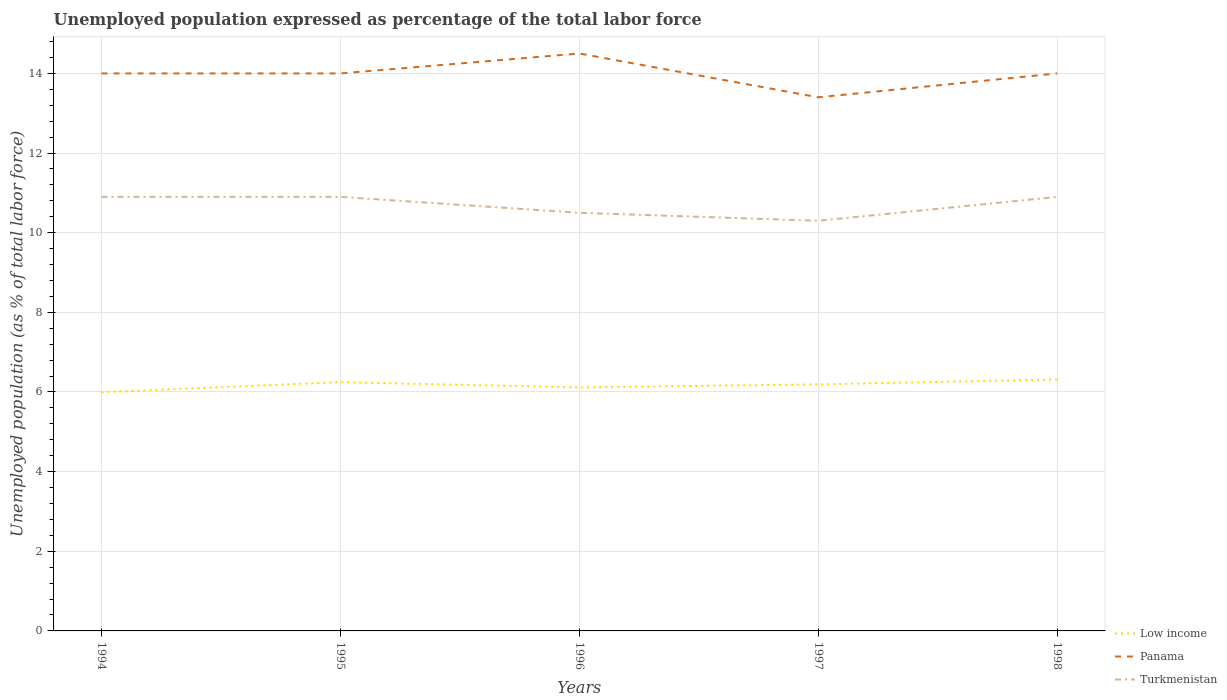Across all years, what is the maximum unemployment in in Turkmenistan?
Your answer should be very brief. 10.3. In which year was the unemployment in in Turkmenistan maximum?
Your answer should be compact. 1997. What is the total unemployment in in Low income in the graph?
Provide a succinct answer. -0.2. What is the difference between the highest and the second highest unemployment in in Low income?
Ensure brevity in your answer.  0.32. What is the difference between the highest and the lowest unemployment in in Low income?
Offer a terse response. 3. Are the values on the major ticks of Y-axis written in scientific E-notation?
Make the answer very short. No. How many legend labels are there?
Give a very brief answer. 3. How are the legend labels stacked?
Provide a short and direct response. Vertical. What is the title of the graph?
Make the answer very short. Unemployed population expressed as percentage of the total labor force. What is the label or title of the X-axis?
Ensure brevity in your answer.  Years. What is the label or title of the Y-axis?
Your answer should be compact. Unemployed population (as % of total labor force). What is the Unemployed population (as % of total labor force) in Low income in 1994?
Your response must be concise. 5.99. What is the Unemployed population (as % of total labor force) of Turkmenistan in 1994?
Keep it short and to the point. 10.9. What is the Unemployed population (as % of total labor force) of Low income in 1995?
Keep it short and to the point. 6.25. What is the Unemployed population (as % of total labor force) in Panama in 1995?
Offer a terse response. 14. What is the Unemployed population (as % of total labor force) in Turkmenistan in 1995?
Keep it short and to the point. 10.9. What is the Unemployed population (as % of total labor force) of Low income in 1996?
Make the answer very short. 6.12. What is the Unemployed population (as % of total labor force) in Turkmenistan in 1996?
Your response must be concise. 10.5. What is the Unemployed population (as % of total labor force) in Low income in 1997?
Keep it short and to the point. 6.19. What is the Unemployed population (as % of total labor force) of Panama in 1997?
Make the answer very short. 13.4. What is the Unemployed population (as % of total labor force) of Turkmenistan in 1997?
Provide a short and direct response. 10.3. What is the Unemployed population (as % of total labor force) in Low income in 1998?
Give a very brief answer. 6.31. What is the Unemployed population (as % of total labor force) of Panama in 1998?
Offer a terse response. 14. What is the Unemployed population (as % of total labor force) in Turkmenistan in 1998?
Ensure brevity in your answer.  10.9. Across all years, what is the maximum Unemployed population (as % of total labor force) in Low income?
Make the answer very short. 6.31. Across all years, what is the maximum Unemployed population (as % of total labor force) of Panama?
Provide a succinct answer. 14.5. Across all years, what is the maximum Unemployed population (as % of total labor force) in Turkmenistan?
Make the answer very short. 10.9. Across all years, what is the minimum Unemployed population (as % of total labor force) in Low income?
Offer a terse response. 5.99. Across all years, what is the minimum Unemployed population (as % of total labor force) of Panama?
Make the answer very short. 13.4. Across all years, what is the minimum Unemployed population (as % of total labor force) of Turkmenistan?
Provide a short and direct response. 10.3. What is the total Unemployed population (as % of total labor force) in Low income in the graph?
Your answer should be very brief. 30.86. What is the total Unemployed population (as % of total labor force) of Panama in the graph?
Offer a terse response. 69.9. What is the total Unemployed population (as % of total labor force) of Turkmenistan in the graph?
Offer a terse response. 53.5. What is the difference between the Unemployed population (as % of total labor force) in Low income in 1994 and that in 1995?
Give a very brief answer. -0.25. What is the difference between the Unemployed population (as % of total labor force) in Low income in 1994 and that in 1996?
Your answer should be compact. -0.12. What is the difference between the Unemployed population (as % of total labor force) in Low income in 1994 and that in 1997?
Give a very brief answer. -0.2. What is the difference between the Unemployed population (as % of total labor force) in Low income in 1994 and that in 1998?
Provide a short and direct response. -0.32. What is the difference between the Unemployed population (as % of total labor force) in Turkmenistan in 1994 and that in 1998?
Your answer should be compact. 0. What is the difference between the Unemployed population (as % of total labor force) in Low income in 1995 and that in 1996?
Give a very brief answer. 0.13. What is the difference between the Unemployed population (as % of total labor force) of Panama in 1995 and that in 1996?
Make the answer very short. -0.5. What is the difference between the Unemployed population (as % of total labor force) of Turkmenistan in 1995 and that in 1996?
Your answer should be compact. 0.4. What is the difference between the Unemployed population (as % of total labor force) in Low income in 1995 and that in 1997?
Offer a very short reply. 0.06. What is the difference between the Unemployed population (as % of total labor force) of Panama in 1995 and that in 1997?
Ensure brevity in your answer.  0.6. What is the difference between the Unemployed population (as % of total labor force) of Low income in 1995 and that in 1998?
Your answer should be compact. -0.07. What is the difference between the Unemployed population (as % of total labor force) in Low income in 1996 and that in 1997?
Make the answer very short. -0.08. What is the difference between the Unemployed population (as % of total labor force) in Low income in 1996 and that in 1998?
Ensure brevity in your answer.  -0.2. What is the difference between the Unemployed population (as % of total labor force) in Panama in 1996 and that in 1998?
Make the answer very short. 0.5. What is the difference between the Unemployed population (as % of total labor force) of Low income in 1997 and that in 1998?
Offer a terse response. -0.12. What is the difference between the Unemployed population (as % of total labor force) of Panama in 1997 and that in 1998?
Provide a succinct answer. -0.6. What is the difference between the Unemployed population (as % of total labor force) of Low income in 1994 and the Unemployed population (as % of total labor force) of Panama in 1995?
Ensure brevity in your answer.  -8.01. What is the difference between the Unemployed population (as % of total labor force) in Low income in 1994 and the Unemployed population (as % of total labor force) in Turkmenistan in 1995?
Your answer should be compact. -4.91. What is the difference between the Unemployed population (as % of total labor force) in Panama in 1994 and the Unemployed population (as % of total labor force) in Turkmenistan in 1995?
Your answer should be compact. 3.1. What is the difference between the Unemployed population (as % of total labor force) of Low income in 1994 and the Unemployed population (as % of total labor force) of Panama in 1996?
Your response must be concise. -8.51. What is the difference between the Unemployed population (as % of total labor force) in Low income in 1994 and the Unemployed population (as % of total labor force) in Turkmenistan in 1996?
Keep it short and to the point. -4.51. What is the difference between the Unemployed population (as % of total labor force) in Low income in 1994 and the Unemployed population (as % of total labor force) in Panama in 1997?
Your answer should be compact. -7.41. What is the difference between the Unemployed population (as % of total labor force) in Low income in 1994 and the Unemployed population (as % of total labor force) in Turkmenistan in 1997?
Make the answer very short. -4.31. What is the difference between the Unemployed population (as % of total labor force) of Panama in 1994 and the Unemployed population (as % of total labor force) of Turkmenistan in 1997?
Your answer should be compact. 3.7. What is the difference between the Unemployed population (as % of total labor force) in Low income in 1994 and the Unemployed population (as % of total labor force) in Panama in 1998?
Your response must be concise. -8.01. What is the difference between the Unemployed population (as % of total labor force) in Low income in 1994 and the Unemployed population (as % of total labor force) in Turkmenistan in 1998?
Your answer should be compact. -4.91. What is the difference between the Unemployed population (as % of total labor force) of Low income in 1995 and the Unemployed population (as % of total labor force) of Panama in 1996?
Your answer should be compact. -8.25. What is the difference between the Unemployed population (as % of total labor force) in Low income in 1995 and the Unemployed population (as % of total labor force) in Turkmenistan in 1996?
Offer a terse response. -4.25. What is the difference between the Unemployed population (as % of total labor force) in Low income in 1995 and the Unemployed population (as % of total labor force) in Panama in 1997?
Give a very brief answer. -7.15. What is the difference between the Unemployed population (as % of total labor force) of Low income in 1995 and the Unemployed population (as % of total labor force) of Turkmenistan in 1997?
Offer a very short reply. -4.05. What is the difference between the Unemployed population (as % of total labor force) of Panama in 1995 and the Unemployed population (as % of total labor force) of Turkmenistan in 1997?
Provide a short and direct response. 3.7. What is the difference between the Unemployed population (as % of total labor force) of Low income in 1995 and the Unemployed population (as % of total labor force) of Panama in 1998?
Ensure brevity in your answer.  -7.75. What is the difference between the Unemployed population (as % of total labor force) of Low income in 1995 and the Unemployed population (as % of total labor force) of Turkmenistan in 1998?
Make the answer very short. -4.65. What is the difference between the Unemployed population (as % of total labor force) of Panama in 1995 and the Unemployed population (as % of total labor force) of Turkmenistan in 1998?
Provide a succinct answer. 3.1. What is the difference between the Unemployed population (as % of total labor force) in Low income in 1996 and the Unemployed population (as % of total labor force) in Panama in 1997?
Provide a succinct answer. -7.28. What is the difference between the Unemployed population (as % of total labor force) of Low income in 1996 and the Unemployed population (as % of total labor force) of Turkmenistan in 1997?
Your answer should be compact. -4.18. What is the difference between the Unemployed population (as % of total labor force) in Low income in 1996 and the Unemployed population (as % of total labor force) in Panama in 1998?
Make the answer very short. -7.88. What is the difference between the Unemployed population (as % of total labor force) in Low income in 1996 and the Unemployed population (as % of total labor force) in Turkmenistan in 1998?
Give a very brief answer. -4.78. What is the difference between the Unemployed population (as % of total labor force) in Low income in 1997 and the Unemployed population (as % of total labor force) in Panama in 1998?
Your response must be concise. -7.81. What is the difference between the Unemployed population (as % of total labor force) in Low income in 1997 and the Unemployed population (as % of total labor force) in Turkmenistan in 1998?
Keep it short and to the point. -4.71. What is the average Unemployed population (as % of total labor force) of Low income per year?
Provide a short and direct response. 6.17. What is the average Unemployed population (as % of total labor force) in Panama per year?
Offer a very short reply. 13.98. In the year 1994, what is the difference between the Unemployed population (as % of total labor force) in Low income and Unemployed population (as % of total labor force) in Panama?
Provide a short and direct response. -8.01. In the year 1994, what is the difference between the Unemployed population (as % of total labor force) of Low income and Unemployed population (as % of total labor force) of Turkmenistan?
Provide a short and direct response. -4.91. In the year 1994, what is the difference between the Unemployed population (as % of total labor force) of Panama and Unemployed population (as % of total labor force) of Turkmenistan?
Ensure brevity in your answer.  3.1. In the year 1995, what is the difference between the Unemployed population (as % of total labor force) in Low income and Unemployed population (as % of total labor force) in Panama?
Offer a very short reply. -7.75. In the year 1995, what is the difference between the Unemployed population (as % of total labor force) of Low income and Unemployed population (as % of total labor force) of Turkmenistan?
Offer a very short reply. -4.65. In the year 1995, what is the difference between the Unemployed population (as % of total labor force) in Panama and Unemployed population (as % of total labor force) in Turkmenistan?
Keep it short and to the point. 3.1. In the year 1996, what is the difference between the Unemployed population (as % of total labor force) in Low income and Unemployed population (as % of total labor force) in Panama?
Give a very brief answer. -8.38. In the year 1996, what is the difference between the Unemployed population (as % of total labor force) of Low income and Unemployed population (as % of total labor force) of Turkmenistan?
Keep it short and to the point. -4.38. In the year 1997, what is the difference between the Unemployed population (as % of total labor force) of Low income and Unemployed population (as % of total labor force) of Panama?
Make the answer very short. -7.21. In the year 1997, what is the difference between the Unemployed population (as % of total labor force) in Low income and Unemployed population (as % of total labor force) in Turkmenistan?
Your response must be concise. -4.11. In the year 1997, what is the difference between the Unemployed population (as % of total labor force) of Panama and Unemployed population (as % of total labor force) of Turkmenistan?
Offer a very short reply. 3.1. In the year 1998, what is the difference between the Unemployed population (as % of total labor force) of Low income and Unemployed population (as % of total labor force) of Panama?
Your response must be concise. -7.69. In the year 1998, what is the difference between the Unemployed population (as % of total labor force) in Low income and Unemployed population (as % of total labor force) in Turkmenistan?
Offer a very short reply. -4.59. In the year 1998, what is the difference between the Unemployed population (as % of total labor force) in Panama and Unemployed population (as % of total labor force) in Turkmenistan?
Offer a terse response. 3.1. What is the ratio of the Unemployed population (as % of total labor force) in Low income in 1994 to that in 1995?
Your answer should be very brief. 0.96. What is the ratio of the Unemployed population (as % of total labor force) in Low income in 1994 to that in 1996?
Offer a very short reply. 0.98. What is the ratio of the Unemployed population (as % of total labor force) of Panama in 1994 to that in 1996?
Ensure brevity in your answer.  0.97. What is the ratio of the Unemployed population (as % of total labor force) of Turkmenistan in 1994 to that in 1996?
Give a very brief answer. 1.04. What is the ratio of the Unemployed population (as % of total labor force) of Low income in 1994 to that in 1997?
Keep it short and to the point. 0.97. What is the ratio of the Unemployed population (as % of total labor force) of Panama in 1994 to that in 1997?
Your answer should be very brief. 1.04. What is the ratio of the Unemployed population (as % of total labor force) of Turkmenistan in 1994 to that in 1997?
Offer a terse response. 1.06. What is the ratio of the Unemployed population (as % of total labor force) in Low income in 1994 to that in 1998?
Your answer should be compact. 0.95. What is the ratio of the Unemployed population (as % of total labor force) in Turkmenistan in 1994 to that in 1998?
Offer a very short reply. 1. What is the ratio of the Unemployed population (as % of total labor force) in Low income in 1995 to that in 1996?
Your answer should be very brief. 1.02. What is the ratio of the Unemployed population (as % of total labor force) of Panama in 1995 to that in 1996?
Offer a terse response. 0.97. What is the ratio of the Unemployed population (as % of total labor force) in Turkmenistan in 1995 to that in 1996?
Offer a terse response. 1.04. What is the ratio of the Unemployed population (as % of total labor force) in Panama in 1995 to that in 1997?
Provide a short and direct response. 1.04. What is the ratio of the Unemployed population (as % of total labor force) in Turkmenistan in 1995 to that in 1997?
Your answer should be very brief. 1.06. What is the ratio of the Unemployed population (as % of total labor force) of Panama in 1995 to that in 1998?
Your response must be concise. 1. What is the ratio of the Unemployed population (as % of total labor force) of Turkmenistan in 1995 to that in 1998?
Your answer should be compact. 1. What is the ratio of the Unemployed population (as % of total labor force) of Panama in 1996 to that in 1997?
Offer a very short reply. 1.08. What is the ratio of the Unemployed population (as % of total labor force) of Turkmenistan in 1996 to that in 1997?
Your response must be concise. 1.02. What is the ratio of the Unemployed population (as % of total labor force) in Low income in 1996 to that in 1998?
Make the answer very short. 0.97. What is the ratio of the Unemployed population (as % of total labor force) of Panama in 1996 to that in 1998?
Your answer should be very brief. 1.04. What is the ratio of the Unemployed population (as % of total labor force) in Turkmenistan in 1996 to that in 1998?
Your answer should be compact. 0.96. What is the ratio of the Unemployed population (as % of total labor force) of Low income in 1997 to that in 1998?
Provide a short and direct response. 0.98. What is the ratio of the Unemployed population (as % of total labor force) in Panama in 1997 to that in 1998?
Offer a terse response. 0.96. What is the ratio of the Unemployed population (as % of total labor force) of Turkmenistan in 1997 to that in 1998?
Your answer should be compact. 0.94. What is the difference between the highest and the second highest Unemployed population (as % of total labor force) of Low income?
Ensure brevity in your answer.  0.07. What is the difference between the highest and the second highest Unemployed population (as % of total labor force) in Panama?
Your response must be concise. 0.5. What is the difference between the highest and the second highest Unemployed population (as % of total labor force) in Turkmenistan?
Make the answer very short. 0. What is the difference between the highest and the lowest Unemployed population (as % of total labor force) of Low income?
Keep it short and to the point. 0.32. What is the difference between the highest and the lowest Unemployed population (as % of total labor force) of Panama?
Provide a succinct answer. 1.1. What is the difference between the highest and the lowest Unemployed population (as % of total labor force) of Turkmenistan?
Your answer should be compact. 0.6. 